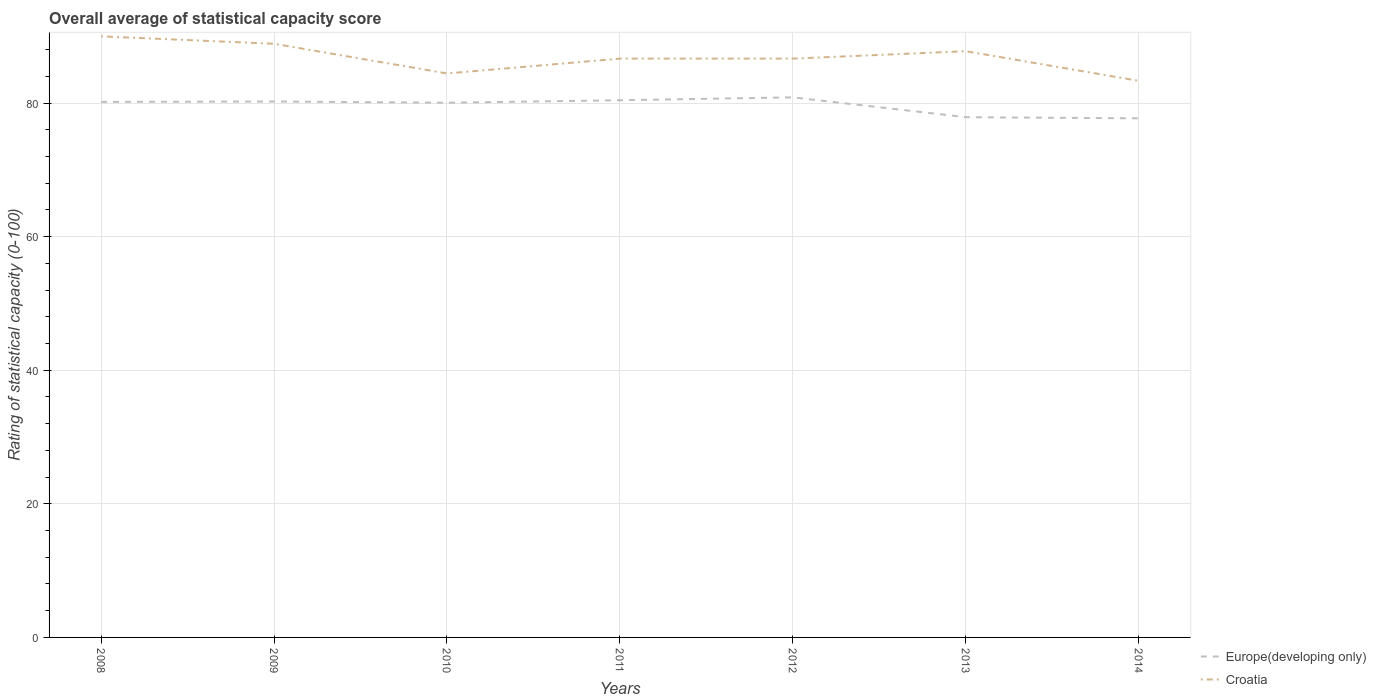Is the number of lines equal to the number of legend labels?
Keep it short and to the point. Yes. Across all years, what is the maximum rating of statistical capacity in Croatia?
Give a very brief answer. 83.33. In which year was the rating of statistical capacity in Croatia maximum?
Offer a terse response. 2014. What is the total rating of statistical capacity in Europe(developing only) in the graph?
Provide a succinct answer. 0.12. What is the difference between the highest and the second highest rating of statistical capacity in Europe(developing only)?
Make the answer very short. 3.14. How many years are there in the graph?
Give a very brief answer. 7. Does the graph contain grids?
Your answer should be very brief. Yes. Where does the legend appear in the graph?
Offer a very short reply. Bottom right. What is the title of the graph?
Provide a succinct answer. Overall average of statistical capacity score. What is the label or title of the X-axis?
Offer a very short reply. Years. What is the label or title of the Y-axis?
Offer a very short reply. Rating of statistical capacity (0-100). What is the Rating of statistical capacity (0-100) of Europe(developing only) in 2008?
Provide a short and direct response. 80.19. What is the Rating of statistical capacity (0-100) in Croatia in 2008?
Your answer should be compact. 90. What is the Rating of statistical capacity (0-100) of Europe(developing only) in 2009?
Ensure brevity in your answer.  80.25. What is the Rating of statistical capacity (0-100) in Croatia in 2009?
Offer a very short reply. 88.89. What is the Rating of statistical capacity (0-100) in Europe(developing only) in 2010?
Offer a terse response. 80.06. What is the Rating of statistical capacity (0-100) in Croatia in 2010?
Provide a short and direct response. 84.44. What is the Rating of statistical capacity (0-100) in Europe(developing only) in 2011?
Your response must be concise. 80.43. What is the Rating of statistical capacity (0-100) in Croatia in 2011?
Provide a succinct answer. 86.67. What is the Rating of statistical capacity (0-100) in Europe(developing only) in 2012?
Provide a succinct answer. 80.86. What is the Rating of statistical capacity (0-100) of Croatia in 2012?
Keep it short and to the point. 86.67. What is the Rating of statistical capacity (0-100) of Europe(developing only) in 2013?
Offer a terse response. 77.89. What is the Rating of statistical capacity (0-100) in Croatia in 2013?
Offer a terse response. 87.78. What is the Rating of statistical capacity (0-100) in Europe(developing only) in 2014?
Offer a terse response. 77.73. What is the Rating of statistical capacity (0-100) of Croatia in 2014?
Your response must be concise. 83.33. Across all years, what is the maximum Rating of statistical capacity (0-100) of Europe(developing only)?
Your response must be concise. 80.86. Across all years, what is the minimum Rating of statistical capacity (0-100) in Europe(developing only)?
Your response must be concise. 77.73. Across all years, what is the minimum Rating of statistical capacity (0-100) in Croatia?
Your answer should be compact. 83.33. What is the total Rating of statistical capacity (0-100) in Europe(developing only) in the graph?
Provide a short and direct response. 557.41. What is the total Rating of statistical capacity (0-100) of Croatia in the graph?
Provide a short and direct response. 607.78. What is the difference between the Rating of statistical capacity (0-100) in Europe(developing only) in 2008 and that in 2009?
Provide a short and direct response. -0.06. What is the difference between the Rating of statistical capacity (0-100) of Europe(developing only) in 2008 and that in 2010?
Make the answer very short. 0.12. What is the difference between the Rating of statistical capacity (0-100) of Croatia in 2008 and that in 2010?
Make the answer very short. 5.56. What is the difference between the Rating of statistical capacity (0-100) in Europe(developing only) in 2008 and that in 2011?
Give a very brief answer. -0.25. What is the difference between the Rating of statistical capacity (0-100) of Croatia in 2008 and that in 2011?
Make the answer very short. 3.33. What is the difference between the Rating of statistical capacity (0-100) in Europe(developing only) in 2008 and that in 2012?
Ensure brevity in your answer.  -0.68. What is the difference between the Rating of statistical capacity (0-100) in Croatia in 2008 and that in 2012?
Provide a short and direct response. 3.33. What is the difference between the Rating of statistical capacity (0-100) in Europe(developing only) in 2008 and that in 2013?
Your answer should be compact. 2.29. What is the difference between the Rating of statistical capacity (0-100) of Croatia in 2008 and that in 2013?
Provide a short and direct response. 2.22. What is the difference between the Rating of statistical capacity (0-100) in Europe(developing only) in 2008 and that in 2014?
Your answer should be compact. 2.46. What is the difference between the Rating of statistical capacity (0-100) in Croatia in 2008 and that in 2014?
Offer a very short reply. 6.67. What is the difference between the Rating of statistical capacity (0-100) of Europe(developing only) in 2009 and that in 2010?
Give a very brief answer. 0.19. What is the difference between the Rating of statistical capacity (0-100) of Croatia in 2009 and that in 2010?
Your answer should be very brief. 4.44. What is the difference between the Rating of statistical capacity (0-100) in Europe(developing only) in 2009 and that in 2011?
Provide a short and direct response. -0.19. What is the difference between the Rating of statistical capacity (0-100) in Croatia in 2009 and that in 2011?
Provide a short and direct response. 2.22. What is the difference between the Rating of statistical capacity (0-100) in Europe(developing only) in 2009 and that in 2012?
Ensure brevity in your answer.  -0.62. What is the difference between the Rating of statistical capacity (0-100) of Croatia in 2009 and that in 2012?
Offer a very short reply. 2.22. What is the difference between the Rating of statistical capacity (0-100) in Europe(developing only) in 2009 and that in 2013?
Offer a terse response. 2.35. What is the difference between the Rating of statistical capacity (0-100) of Europe(developing only) in 2009 and that in 2014?
Offer a very short reply. 2.52. What is the difference between the Rating of statistical capacity (0-100) of Croatia in 2009 and that in 2014?
Your answer should be very brief. 5.56. What is the difference between the Rating of statistical capacity (0-100) of Europe(developing only) in 2010 and that in 2011?
Provide a succinct answer. -0.37. What is the difference between the Rating of statistical capacity (0-100) of Croatia in 2010 and that in 2011?
Offer a very short reply. -2.22. What is the difference between the Rating of statistical capacity (0-100) of Europe(developing only) in 2010 and that in 2012?
Your answer should be compact. -0.8. What is the difference between the Rating of statistical capacity (0-100) in Croatia in 2010 and that in 2012?
Give a very brief answer. -2.22. What is the difference between the Rating of statistical capacity (0-100) of Europe(developing only) in 2010 and that in 2013?
Your response must be concise. 2.17. What is the difference between the Rating of statistical capacity (0-100) of Croatia in 2010 and that in 2013?
Offer a very short reply. -3.33. What is the difference between the Rating of statistical capacity (0-100) of Europe(developing only) in 2010 and that in 2014?
Give a very brief answer. 2.34. What is the difference between the Rating of statistical capacity (0-100) of Croatia in 2010 and that in 2014?
Provide a succinct answer. 1.11. What is the difference between the Rating of statistical capacity (0-100) of Europe(developing only) in 2011 and that in 2012?
Make the answer very short. -0.43. What is the difference between the Rating of statistical capacity (0-100) of Europe(developing only) in 2011 and that in 2013?
Make the answer very short. 2.54. What is the difference between the Rating of statistical capacity (0-100) in Croatia in 2011 and that in 2013?
Your answer should be compact. -1.11. What is the difference between the Rating of statistical capacity (0-100) in Europe(developing only) in 2011 and that in 2014?
Provide a short and direct response. 2.71. What is the difference between the Rating of statistical capacity (0-100) of Europe(developing only) in 2012 and that in 2013?
Give a very brief answer. 2.97. What is the difference between the Rating of statistical capacity (0-100) in Croatia in 2012 and that in 2013?
Keep it short and to the point. -1.11. What is the difference between the Rating of statistical capacity (0-100) in Europe(developing only) in 2012 and that in 2014?
Keep it short and to the point. 3.14. What is the difference between the Rating of statistical capacity (0-100) in Croatia in 2012 and that in 2014?
Offer a terse response. 3.33. What is the difference between the Rating of statistical capacity (0-100) in Europe(developing only) in 2013 and that in 2014?
Give a very brief answer. 0.17. What is the difference between the Rating of statistical capacity (0-100) in Croatia in 2013 and that in 2014?
Your answer should be compact. 4.44. What is the difference between the Rating of statistical capacity (0-100) in Europe(developing only) in 2008 and the Rating of statistical capacity (0-100) in Croatia in 2009?
Give a very brief answer. -8.7. What is the difference between the Rating of statistical capacity (0-100) in Europe(developing only) in 2008 and the Rating of statistical capacity (0-100) in Croatia in 2010?
Your answer should be very brief. -4.26. What is the difference between the Rating of statistical capacity (0-100) of Europe(developing only) in 2008 and the Rating of statistical capacity (0-100) of Croatia in 2011?
Provide a succinct answer. -6.48. What is the difference between the Rating of statistical capacity (0-100) in Europe(developing only) in 2008 and the Rating of statistical capacity (0-100) in Croatia in 2012?
Provide a short and direct response. -6.48. What is the difference between the Rating of statistical capacity (0-100) of Europe(developing only) in 2008 and the Rating of statistical capacity (0-100) of Croatia in 2013?
Your answer should be very brief. -7.59. What is the difference between the Rating of statistical capacity (0-100) of Europe(developing only) in 2008 and the Rating of statistical capacity (0-100) of Croatia in 2014?
Your answer should be compact. -3.15. What is the difference between the Rating of statistical capacity (0-100) in Europe(developing only) in 2009 and the Rating of statistical capacity (0-100) in Croatia in 2010?
Ensure brevity in your answer.  -4.2. What is the difference between the Rating of statistical capacity (0-100) of Europe(developing only) in 2009 and the Rating of statistical capacity (0-100) of Croatia in 2011?
Ensure brevity in your answer.  -6.42. What is the difference between the Rating of statistical capacity (0-100) of Europe(developing only) in 2009 and the Rating of statistical capacity (0-100) of Croatia in 2012?
Give a very brief answer. -6.42. What is the difference between the Rating of statistical capacity (0-100) in Europe(developing only) in 2009 and the Rating of statistical capacity (0-100) in Croatia in 2013?
Your answer should be compact. -7.53. What is the difference between the Rating of statistical capacity (0-100) in Europe(developing only) in 2009 and the Rating of statistical capacity (0-100) in Croatia in 2014?
Provide a succinct answer. -3.09. What is the difference between the Rating of statistical capacity (0-100) in Europe(developing only) in 2010 and the Rating of statistical capacity (0-100) in Croatia in 2011?
Provide a succinct answer. -6.61. What is the difference between the Rating of statistical capacity (0-100) of Europe(developing only) in 2010 and the Rating of statistical capacity (0-100) of Croatia in 2012?
Make the answer very short. -6.61. What is the difference between the Rating of statistical capacity (0-100) of Europe(developing only) in 2010 and the Rating of statistical capacity (0-100) of Croatia in 2013?
Provide a short and direct response. -7.72. What is the difference between the Rating of statistical capacity (0-100) of Europe(developing only) in 2010 and the Rating of statistical capacity (0-100) of Croatia in 2014?
Keep it short and to the point. -3.27. What is the difference between the Rating of statistical capacity (0-100) of Europe(developing only) in 2011 and the Rating of statistical capacity (0-100) of Croatia in 2012?
Ensure brevity in your answer.  -6.23. What is the difference between the Rating of statistical capacity (0-100) of Europe(developing only) in 2011 and the Rating of statistical capacity (0-100) of Croatia in 2013?
Your response must be concise. -7.35. What is the difference between the Rating of statistical capacity (0-100) in Europe(developing only) in 2011 and the Rating of statistical capacity (0-100) in Croatia in 2014?
Your answer should be very brief. -2.9. What is the difference between the Rating of statistical capacity (0-100) of Europe(developing only) in 2012 and the Rating of statistical capacity (0-100) of Croatia in 2013?
Your answer should be compact. -6.91. What is the difference between the Rating of statistical capacity (0-100) of Europe(developing only) in 2012 and the Rating of statistical capacity (0-100) of Croatia in 2014?
Make the answer very short. -2.47. What is the difference between the Rating of statistical capacity (0-100) in Europe(developing only) in 2013 and the Rating of statistical capacity (0-100) in Croatia in 2014?
Your answer should be very brief. -5.44. What is the average Rating of statistical capacity (0-100) in Europe(developing only) per year?
Make the answer very short. 79.63. What is the average Rating of statistical capacity (0-100) in Croatia per year?
Ensure brevity in your answer.  86.83. In the year 2008, what is the difference between the Rating of statistical capacity (0-100) of Europe(developing only) and Rating of statistical capacity (0-100) of Croatia?
Keep it short and to the point. -9.81. In the year 2009, what is the difference between the Rating of statistical capacity (0-100) of Europe(developing only) and Rating of statistical capacity (0-100) of Croatia?
Your answer should be very brief. -8.64. In the year 2010, what is the difference between the Rating of statistical capacity (0-100) of Europe(developing only) and Rating of statistical capacity (0-100) of Croatia?
Your response must be concise. -4.38. In the year 2011, what is the difference between the Rating of statistical capacity (0-100) in Europe(developing only) and Rating of statistical capacity (0-100) in Croatia?
Make the answer very short. -6.23. In the year 2012, what is the difference between the Rating of statistical capacity (0-100) of Europe(developing only) and Rating of statistical capacity (0-100) of Croatia?
Offer a very short reply. -5.8. In the year 2013, what is the difference between the Rating of statistical capacity (0-100) of Europe(developing only) and Rating of statistical capacity (0-100) of Croatia?
Offer a terse response. -9.88. In the year 2014, what is the difference between the Rating of statistical capacity (0-100) in Europe(developing only) and Rating of statistical capacity (0-100) in Croatia?
Your response must be concise. -5.61. What is the ratio of the Rating of statistical capacity (0-100) of Croatia in 2008 to that in 2009?
Provide a short and direct response. 1.01. What is the ratio of the Rating of statistical capacity (0-100) in Europe(developing only) in 2008 to that in 2010?
Make the answer very short. 1. What is the ratio of the Rating of statistical capacity (0-100) of Croatia in 2008 to that in 2010?
Make the answer very short. 1.07. What is the ratio of the Rating of statistical capacity (0-100) of Europe(developing only) in 2008 to that in 2011?
Your answer should be compact. 1. What is the ratio of the Rating of statistical capacity (0-100) in Europe(developing only) in 2008 to that in 2013?
Offer a terse response. 1.03. What is the ratio of the Rating of statistical capacity (0-100) of Croatia in 2008 to that in 2013?
Provide a succinct answer. 1.03. What is the ratio of the Rating of statistical capacity (0-100) of Europe(developing only) in 2008 to that in 2014?
Your response must be concise. 1.03. What is the ratio of the Rating of statistical capacity (0-100) in Croatia in 2008 to that in 2014?
Make the answer very short. 1.08. What is the ratio of the Rating of statistical capacity (0-100) of Europe(developing only) in 2009 to that in 2010?
Your answer should be compact. 1. What is the ratio of the Rating of statistical capacity (0-100) of Croatia in 2009 to that in 2010?
Your answer should be very brief. 1.05. What is the ratio of the Rating of statistical capacity (0-100) of Croatia in 2009 to that in 2011?
Your response must be concise. 1.03. What is the ratio of the Rating of statistical capacity (0-100) in Croatia in 2009 to that in 2012?
Offer a terse response. 1.03. What is the ratio of the Rating of statistical capacity (0-100) of Europe(developing only) in 2009 to that in 2013?
Your answer should be compact. 1.03. What is the ratio of the Rating of statistical capacity (0-100) of Croatia in 2009 to that in 2013?
Ensure brevity in your answer.  1.01. What is the ratio of the Rating of statistical capacity (0-100) of Europe(developing only) in 2009 to that in 2014?
Your answer should be compact. 1.03. What is the ratio of the Rating of statistical capacity (0-100) in Croatia in 2009 to that in 2014?
Provide a succinct answer. 1.07. What is the ratio of the Rating of statistical capacity (0-100) of Croatia in 2010 to that in 2011?
Offer a very short reply. 0.97. What is the ratio of the Rating of statistical capacity (0-100) of Croatia in 2010 to that in 2012?
Keep it short and to the point. 0.97. What is the ratio of the Rating of statistical capacity (0-100) of Europe(developing only) in 2010 to that in 2013?
Your answer should be very brief. 1.03. What is the ratio of the Rating of statistical capacity (0-100) of Europe(developing only) in 2010 to that in 2014?
Provide a succinct answer. 1.03. What is the ratio of the Rating of statistical capacity (0-100) of Croatia in 2010 to that in 2014?
Your answer should be compact. 1.01. What is the ratio of the Rating of statistical capacity (0-100) in Europe(developing only) in 2011 to that in 2012?
Offer a terse response. 0.99. What is the ratio of the Rating of statistical capacity (0-100) of Europe(developing only) in 2011 to that in 2013?
Provide a short and direct response. 1.03. What is the ratio of the Rating of statistical capacity (0-100) in Croatia in 2011 to that in 2013?
Offer a very short reply. 0.99. What is the ratio of the Rating of statistical capacity (0-100) in Europe(developing only) in 2011 to that in 2014?
Make the answer very short. 1.03. What is the ratio of the Rating of statistical capacity (0-100) in Croatia in 2011 to that in 2014?
Keep it short and to the point. 1.04. What is the ratio of the Rating of statistical capacity (0-100) of Europe(developing only) in 2012 to that in 2013?
Your answer should be compact. 1.04. What is the ratio of the Rating of statistical capacity (0-100) in Croatia in 2012 to that in 2013?
Ensure brevity in your answer.  0.99. What is the ratio of the Rating of statistical capacity (0-100) of Europe(developing only) in 2012 to that in 2014?
Offer a terse response. 1.04. What is the ratio of the Rating of statistical capacity (0-100) in Europe(developing only) in 2013 to that in 2014?
Ensure brevity in your answer.  1. What is the ratio of the Rating of statistical capacity (0-100) of Croatia in 2013 to that in 2014?
Provide a short and direct response. 1.05. What is the difference between the highest and the second highest Rating of statistical capacity (0-100) of Europe(developing only)?
Your response must be concise. 0.43. What is the difference between the highest and the lowest Rating of statistical capacity (0-100) of Europe(developing only)?
Ensure brevity in your answer.  3.14. What is the difference between the highest and the lowest Rating of statistical capacity (0-100) in Croatia?
Keep it short and to the point. 6.67. 